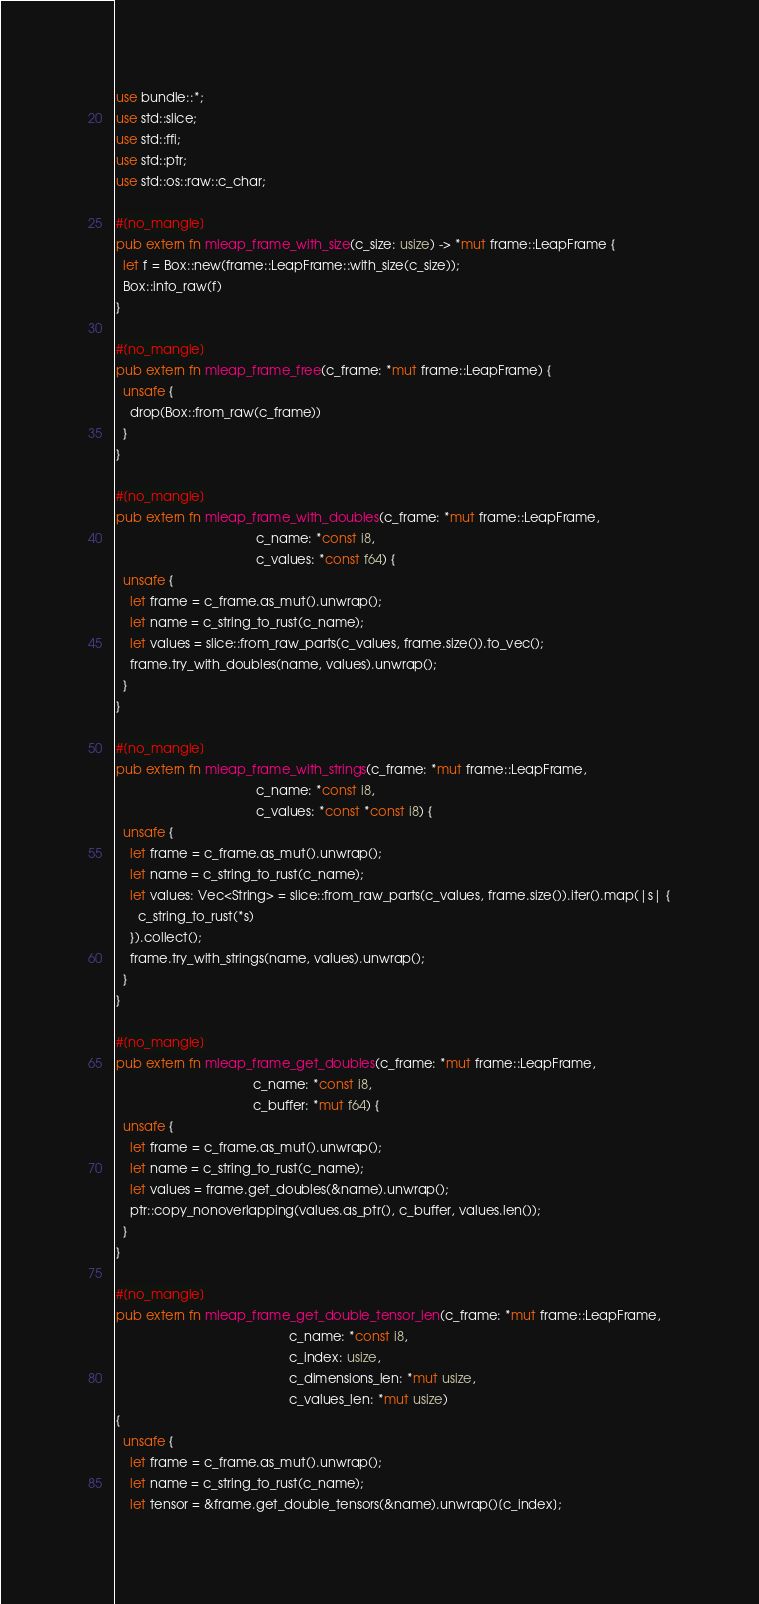Convert code to text. <code><loc_0><loc_0><loc_500><loc_500><_Rust_>use bundle::*;
use std::slice;
use std::ffi;
use std::ptr;
use std::os::raw::c_char;

#[no_mangle]
pub extern fn mleap_frame_with_size(c_size: usize) -> *mut frame::LeapFrame {
  let f = Box::new(frame::LeapFrame::with_size(c_size));
  Box::into_raw(f)
}

#[no_mangle]
pub extern fn mleap_frame_free(c_frame: *mut frame::LeapFrame) {
  unsafe {
    drop(Box::from_raw(c_frame))
  }
}

#[no_mangle]
pub extern fn mleap_frame_with_doubles(c_frame: *mut frame::LeapFrame,
                                       c_name: *const i8,
                                       c_values: *const f64) {
  unsafe {
    let frame = c_frame.as_mut().unwrap();
    let name = c_string_to_rust(c_name);
    let values = slice::from_raw_parts(c_values, frame.size()).to_vec();
    frame.try_with_doubles(name, values).unwrap();
  }
}

#[no_mangle]
pub extern fn mleap_frame_with_strings(c_frame: *mut frame::LeapFrame,
                                       c_name: *const i8,
                                       c_values: *const *const i8) {
  unsafe {
    let frame = c_frame.as_mut().unwrap();
    let name = c_string_to_rust(c_name);
    let values: Vec<String> = slice::from_raw_parts(c_values, frame.size()).iter().map(|s| {
      c_string_to_rust(*s)
    }).collect();
    frame.try_with_strings(name, values).unwrap();
  }
}

#[no_mangle]
pub extern fn mleap_frame_get_doubles(c_frame: *mut frame::LeapFrame,
                                      c_name: *const i8,
                                      c_buffer: *mut f64) {
  unsafe {
    let frame = c_frame.as_mut().unwrap();
    let name = c_string_to_rust(c_name);
    let values = frame.get_doubles(&name).unwrap();
    ptr::copy_nonoverlapping(values.as_ptr(), c_buffer, values.len());
  }
}

#[no_mangle]
pub extern fn mleap_frame_get_double_tensor_len(c_frame: *mut frame::LeapFrame,
                                                c_name: *const i8,
                                                c_index: usize,
                                                c_dimensions_len: *mut usize,
                                                c_values_len: *mut usize)
{
  unsafe {
    let frame = c_frame.as_mut().unwrap();
    let name = c_string_to_rust(c_name);
    let tensor = &frame.get_double_tensors(&name).unwrap()[c_index];</code> 